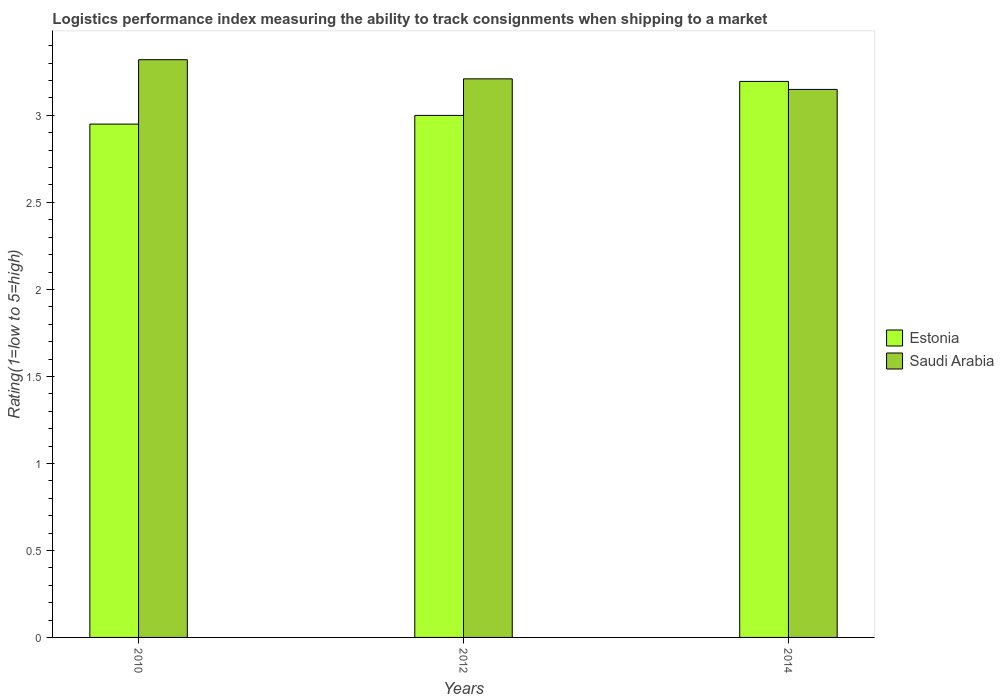How many different coloured bars are there?
Offer a terse response. 2. How many groups of bars are there?
Your answer should be compact. 3. Are the number of bars per tick equal to the number of legend labels?
Your answer should be very brief. Yes. Are the number of bars on each tick of the X-axis equal?
Offer a very short reply. Yes. How many bars are there on the 1st tick from the right?
Ensure brevity in your answer.  2. What is the label of the 1st group of bars from the left?
Make the answer very short. 2010. In how many cases, is the number of bars for a given year not equal to the number of legend labels?
Give a very brief answer. 0. What is the Logistic performance index in Saudi Arabia in 2014?
Give a very brief answer. 3.15. Across all years, what is the maximum Logistic performance index in Saudi Arabia?
Offer a terse response. 3.32. Across all years, what is the minimum Logistic performance index in Saudi Arabia?
Ensure brevity in your answer.  3.15. In which year was the Logistic performance index in Estonia maximum?
Your answer should be compact. 2014. What is the total Logistic performance index in Saudi Arabia in the graph?
Make the answer very short. 9.68. What is the difference between the Logistic performance index in Saudi Arabia in 2010 and that in 2014?
Your answer should be very brief. 0.17. What is the difference between the Logistic performance index in Saudi Arabia in 2014 and the Logistic performance index in Estonia in 2012?
Provide a succinct answer. 0.15. What is the average Logistic performance index in Saudi Arabia per year?
Provide a short and direct response. 3.23. In the year 2012, what is the difference between the Logistic performance index in Saudi Arabia and Logistic performance index in Estonia?
Keep it short and to the point. 0.21. In how many years, is the Logistic performance index in Estonia greater than 2.5?
Provide a succinct answer. 3. What is the ratio of the Logistic performance index in Estonia in 2012 to that in 2014?
Your answer should be very brief. 0.94. Is the difference between the Logistic performance index in Saudi Arabia in 2010 and 2014 greater than the difference between the Logistic performance index in Estonia in 2010 and 2014?
Provide a short and direct response. Yes. What is the difference between the highest and the second highest Logistic performance index in Saudi Arabia?
Offer a terse response. 0.11. What is the difference between the highest and the lowest Logistic performance index in Estonia?
Your response must be concise. 0.25. In how many years, is the Logistic performance index in Estonia greater than the average Logistic performance index in Estonia taken over all years?
Your answer should be very brief. 1. What does the 2nd bar from the left in 2010 represents?
Give a very brief answer. Saudi Arabia. What does the 1st bar from the right in 2014 represents?
Offer a very short reply. Saudi Arabia. Are all the bars in the graph horizontal?
Provide a short and direct response. No. How many years are there in the graph?
Keep it short and to the point. 3. What is the difference between two consecutive major ticks on the Y-axis?
Ensure brevity in your answer.  0.5. Does the graph contain any zero values?
Keep it short and to the point. No. How many legend labels are there?
Your answer should be compact. 2. How are the legend labels stacked?
Make the answer very short. Vertical. What is the title of the graph?
Give a very brief answer. Logistics performance index measuring the ability to track consignments when shipping to a market. What is the label or title of the X-axis?
Ensure brevity in your answer.  Years. What is the label or title of the Y-axis?
Keep it short and to the point. Rating(1=low to 5=high). What is the Rating(1=low to 5=high) of Estonia in 2010?
Make the answer very short. 2.95. What is the Rating(1=low to 5=high) in Saudi Arabia in 2010?
Offer a terse response. 3.32. What is the Rating(1=low to 5=high) of Estonia in 2012?
Your response must be concise. 3. What is the Rating(1=low to 5=high) of Saudi Arabia in 2012?
Your answer should be compact. 3.21. What is the Rating(1=low to 5=high) of Estonia in 2014?
Offer a terse response. 3.2. What is the Rating(1=low to 5=high) of Saudi Arabia in 2014?
Your answer should be compact. 3.15. Across all years, what is the maximum Rating(1=low to 5=high) in Estonia?
Offer a terse response. 3.2. Across all years, what is the maximum Rating(1=low to 5=high) of Saudi Arabia?
Provide a short and direct response. 3.32. Across all years, what is the minimum Rating(1=low to 5=high) of Estonia?
Your response must be concise. 2.95. Across all years, what is the minimum Rating(1=low to 5=high) in Saudi Arabia?
Give a very brief answer. 3.15. What is the total Rating(1=low to 5=high) in Estonia in the graph?
Your answer should be very brief. 9.15. What is the total Rating(1=low to 5=high) in Saudi Arabia in the graph?
Make the answer very short. 9.68. What is the difference between the Rating(1=low to 5=high) of Estonia in 2010 and that in 2012?
Keep it short and to the point. -0.05. What is the difference between the Rating(1=low to 5=high) of Saudi Arabia in 2010 and that in 2012?
Keep it short and to the point. 0.11. What is the difference between the Rating(1=low to 5=high) of Estonia in 2010 and that in 2014?
Ensure brevity in your answer.  -0.25. What is the difference between the Rating(1=low to 5=high) of Saudi Arabia in 2010 and that in 2014?
Keep it short and to the point. 0.17. What is the difference between the Rating(1=low to 5=high) of Estonia in 2012 and that in 2014?
Give a very brief answer. -0.2. What is the difference between the Rating(1=low to 5=high) in Saudi Arabia in 2012 and that in 2014?
Make the answer very short. 0.06. What is the difference between the Rating(1=low to 5=high) of Estonia in 2010 and the Rating(1=low to 5=high) of Saudi Arabia in 2012?
Your response must be concise. -0.26. What is the difference between the Rating(1=low to 5=high) in Estonia in 2010 and the Rating(1=low to 5=high) in Saudi Arabia in 2014?
Ensure brevity in your answer.  -0.2. What is the difference between the Rating(1=low to 5=high) in Estonia in 2012 and the Rating(1=low to 5=high) in Saudi Arabia in 2014?
Make the answer very short. -0.15. What is the average Rating(1=low to 5=high) in Estonia per year?
Offer a very short reply. 3.05. What is the average Rating(1=low to 5=high) of Saudi Arabia per year?
Offer a terse response. 3.23. In the year 2010, what is the difference between the Rating(1=low to 5=high) in Estonia and Rating(1=low to 5=high) in Saudi Arabia?
Give a very brief answer. -0.37. In the year 2012, what is the difference between the Rating(1=low to 5=high) of Estonia and Rating(1=low to 5=high) of Saudi Arabia?
Make the answer very short. -0.21. In the year 2014, what is the difference between the Rating(1=low to 5=high) in Estonia and Rating(1=low to 5=high) in Saudi Arabia?
Ensure brevity in your answer.  0.05. What is the ratio of the Rating(1=low to 5=high) of Estonia in 2010 to that in 2012?
Your answer should be very brief. 0.98. What is the ratio of the Rating(1=low to 5=high) of Saudi Arabia in 2010 to that in 2012?
Your answer should be very brief. 1.03. What is the ratio of the Rating(1=low to 5=high) in Estonia in 2010 to that in 2014?
Give a very brief answer. 0.92. What is the ratio of the Rating(1=low to 5=high) of Saudi Arabia in 2010 to that in 2014?
Your response must be concise. 1.05. What is the ratio of the Rating(1=low to 5=high) in Estonia in 2012 to that in 2014?
Your answer should be very brief. 0.94. What is the ratio of the Rating(1=low to 5=high) in Saudi Arabia in 2012 to that in 2014?
Your response must be concise. 1.02. What is the difference between the highest and the second highest Rating(1=low to 5=high) of Estonia?
Ensure brevity in your answer.  0.2. What is the difference between the highest and the second highest Rating(1=low to 5=high) in Saudi Arabia?
Provide a short and direct response. 0.11. What is the difference between the highest and the lowest Rating(1=low to 5=high) of Estonia?
Provide a short and direct response. 0.25. What is the difference between the highest and the lowest Rating(1=low to 5=high) in Saudi Arabia?
Keep it short and to the point. 0.17. 